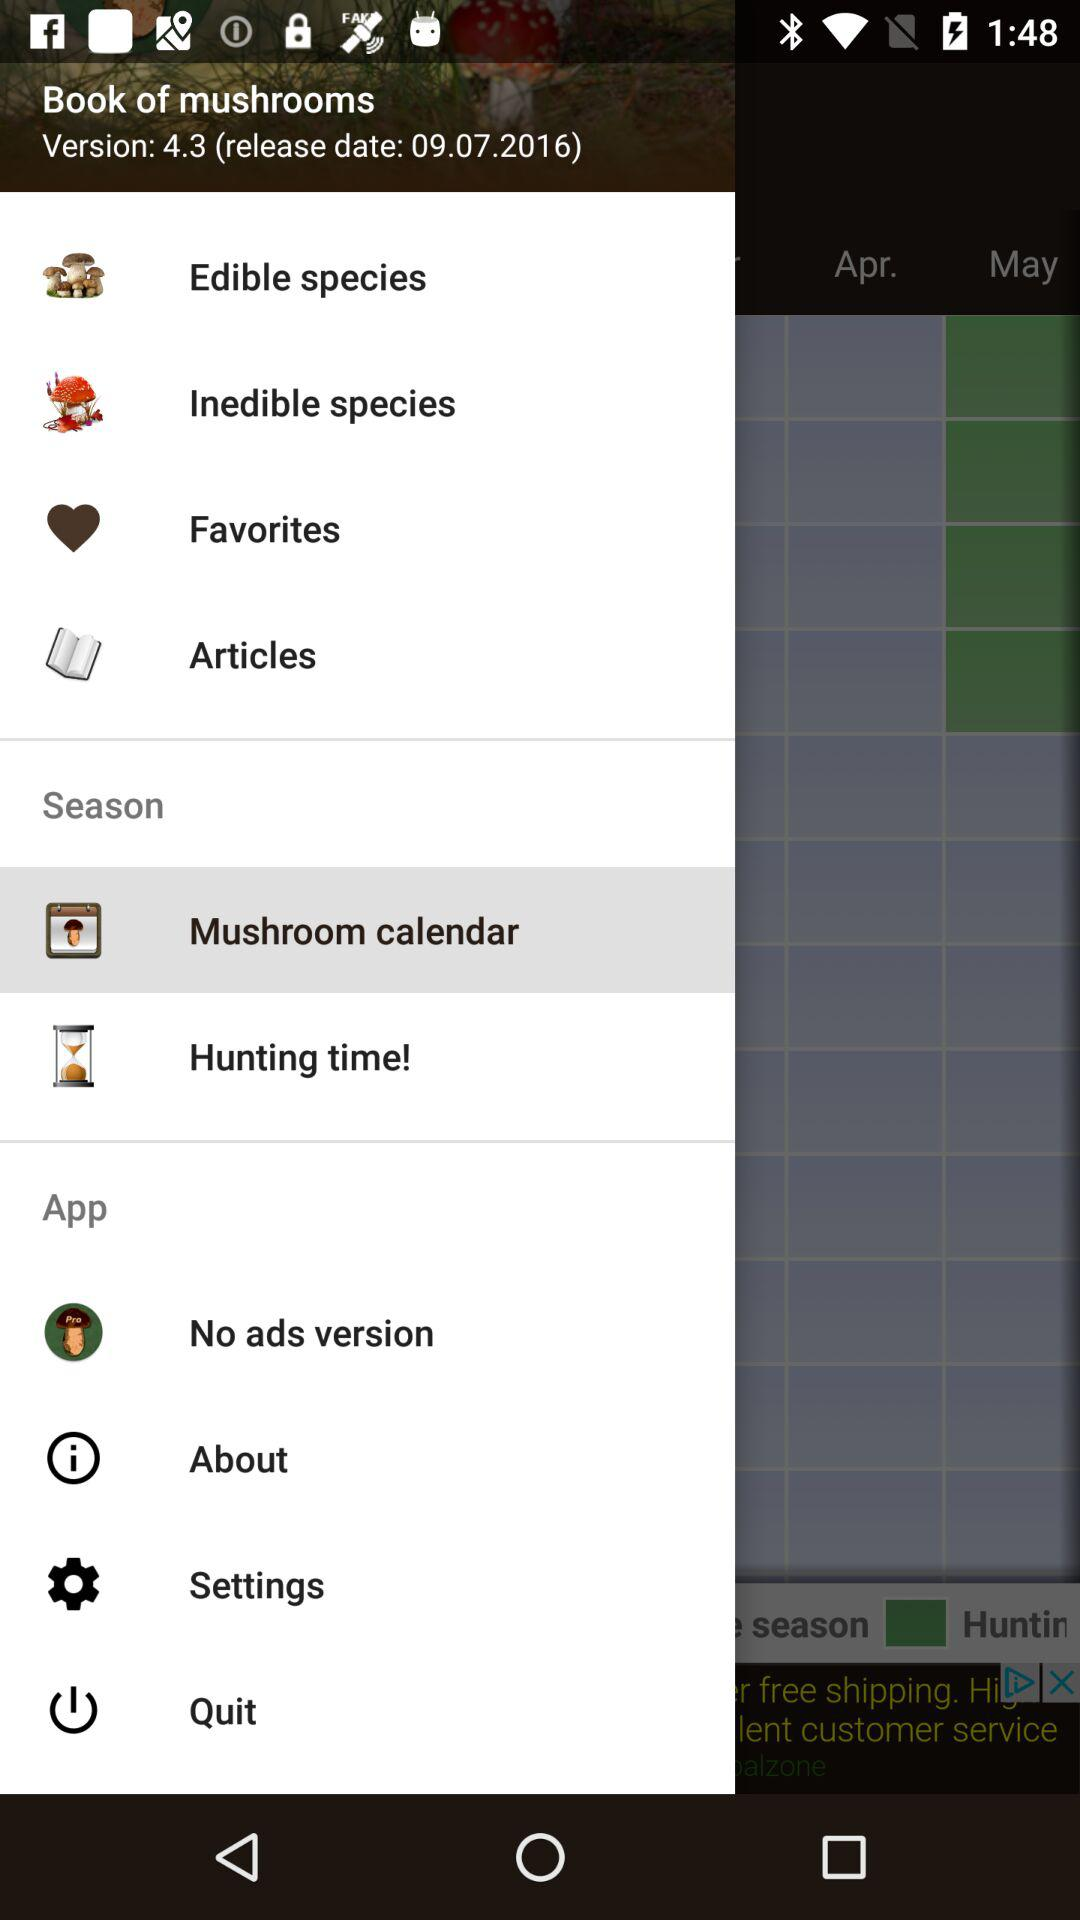What is the version of the application? The version of the application is 4.3. 